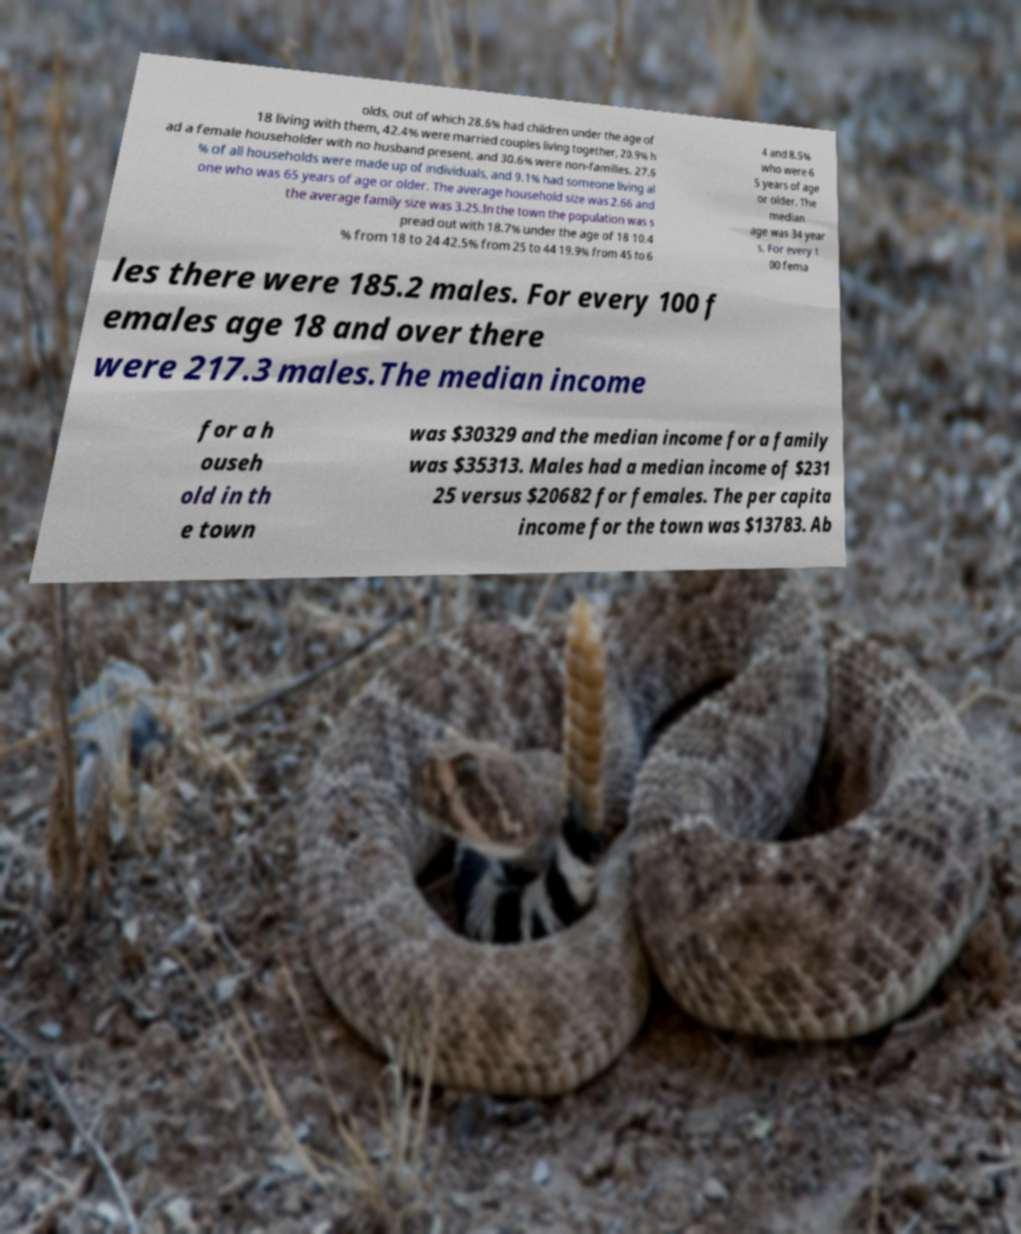Could you extract and type out the text from this image? olds, out of which 28.6% had children under the age of 18 living with them, 42.4% were married couples living together, 20.9% h ad a female householder with no husband present, and 30.6% were non-families. 27.6 % of all households were made up of individuals, and 9.1% had someone living al one who was 65 years of age or older. The average household size was 2.66 and the average family size was 3.25.In the town the population was s pread out with 18.7% under the age of 18 10.4 % from 18 to 24 42.5% from 25 to 44 19.9% from 45 to 6 4 and 8.5% who were 6 5 years of age or older. The median age was 34 year s. For every 1 00 fema les there were 185.2 males. For every 100 f emales age 18 and over there were 217.3 males.The median income for a h ouseh old in th e town was $30329 and the median income for a family was $35313. Males had a median income of $231 25 versus $20682 for females. The per capita income for the town was $13783. Ab 